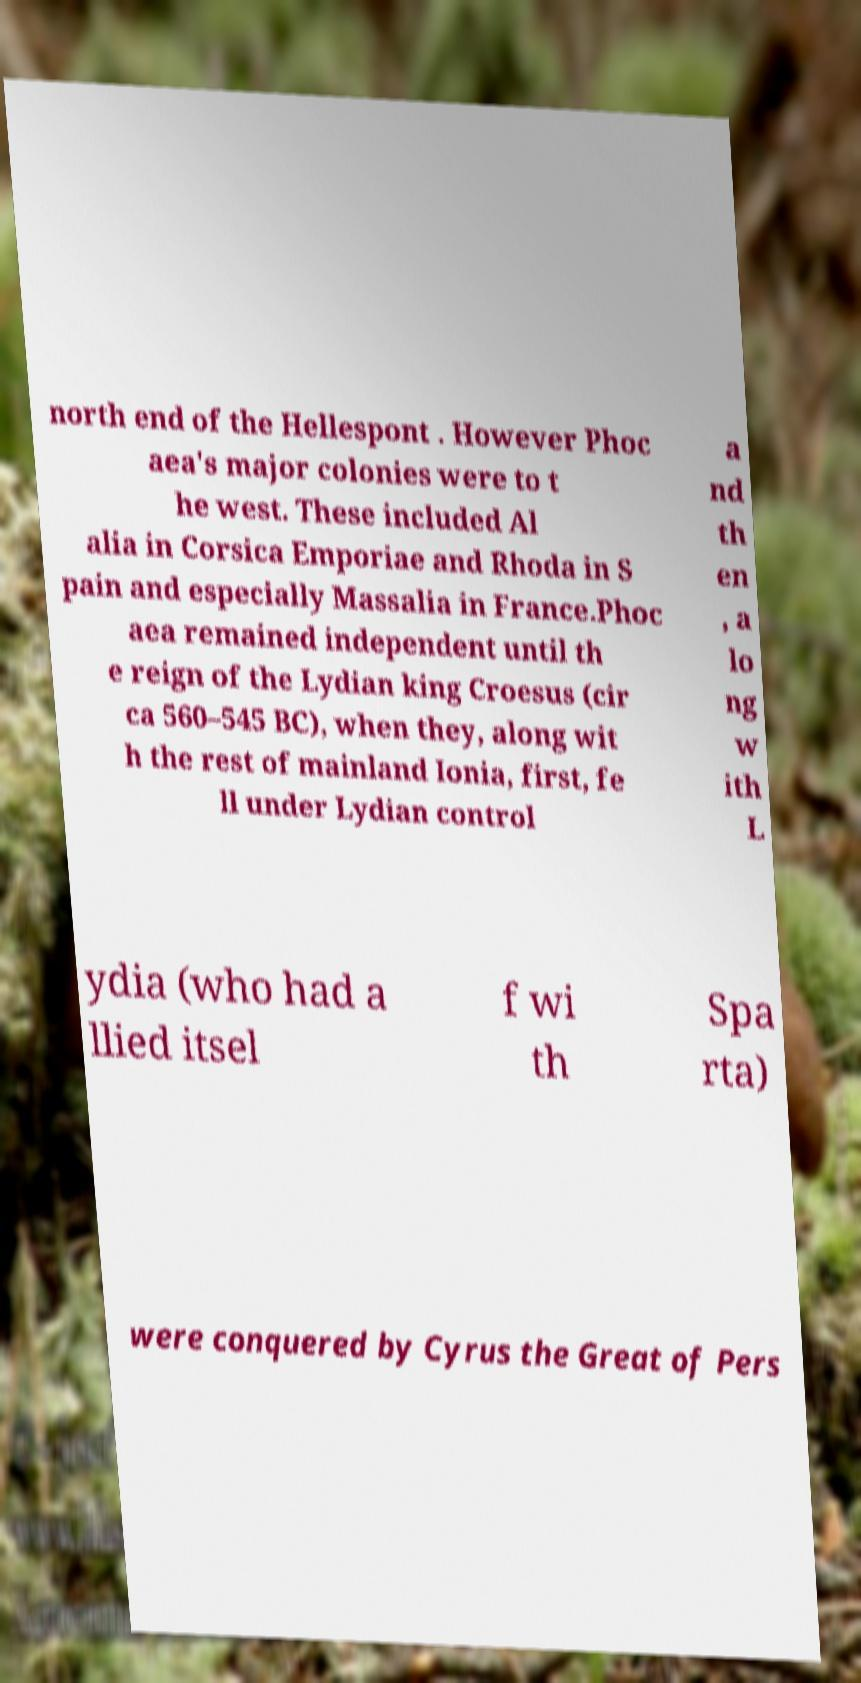For documentation purposes, I need the text within this image transcribed. Could you provide that? north end of the Hellespont . However Phoc aea's major colonies were to t he west. These included Al alia in Corsica Emporiae and Rhoda in S pain and especially Massalia in France.Phoc aea remained independent until th e reign of the Lydian king Croesus (cir ca 560–545 BC), when they, along wit h the rest of mainland Ionia, first, fe ll under Lydian control a nd th en , a lo ng w ith L ydia (who had a llied itsel f wi th Spa rta) were conquered by Cyrus the Great of Pers 